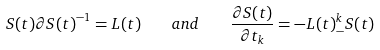<formula> <loc_0><loc_0><loc_500><loc_500>S ( t ) \partial { S ( t ) } ^ { - 1 } = L ( t ) \quad a n d \quad \frac { \partial { S ( t ) } } { \partial { t _ { k } } } = - L ( t ) ^ { k } _ { - } S ( t )</formula> 